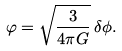<formula> <loc_0><loc_0><loc_500><loc_500>\varphi = \sqrt { \frac { 3 } { 4 \pi G } } \, \delta \phi .</formula> 